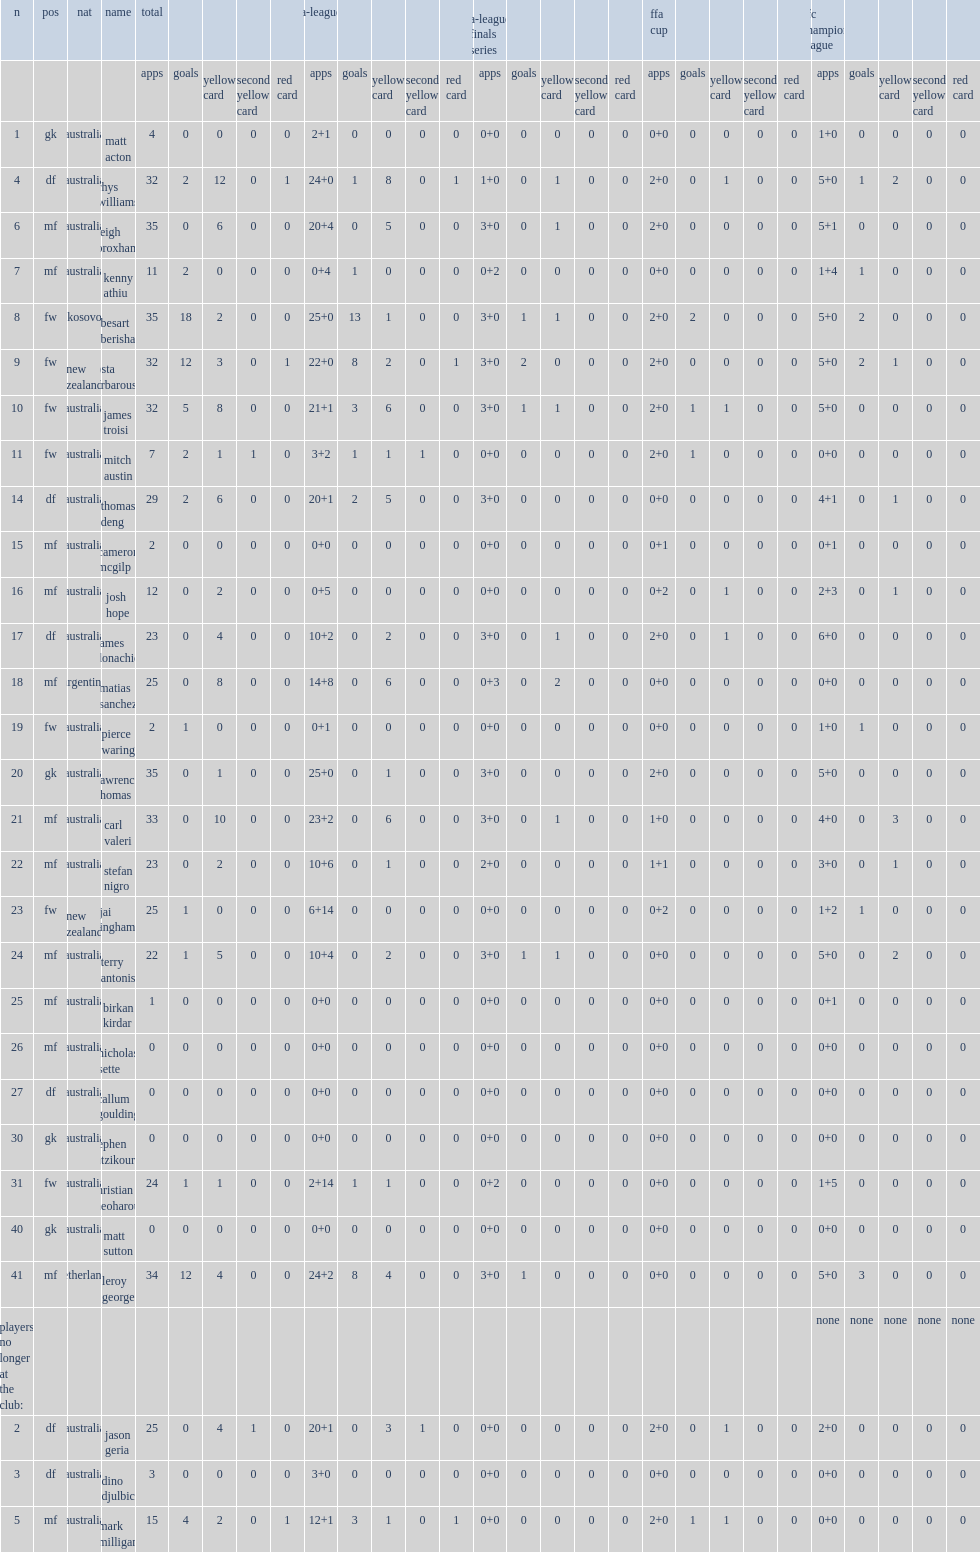List the matches that the melbourne victory fc participated in. A-league ffa cup afc champions league. Help me parse the entirety of this table. {'header': ['n', 'pos', 'nat', 'name', 'total', '', '', '', '', 'a-league', '', '', '', '', 'a-league finals series', '', '', '', '', 'ffa cup', '', '', '', '', 'afc champions league', '', '', '', ''], 'rows': [['', '', '', '', 'apps', 'goals', 'yellow card', 'second yellow card', 'red card', 'apps', 'goals', 'yellow card', 'second yellow card', 'red card', 'apps', 'goals', 'yellow card', 'second yellow card', 'red card', 'apps', 'goals', 'yellow card', 'second yellow card', 'red card', 'apps', 'goals', 'yellow card', 'second yellow card', 'red card'], ['1', 'gk', 'australia', 'matt acton', '4', '0', '0', '0', '0', '2+1', '0', '0', '0', '0', '0+0', '0', '0', '0', '0', '0+0', '0', '0', '0', '0', '1+0', '0', '0', '0', '0'], ['4', 'df', 'australia', 'rhys williams', '32', '2', '12', '0', '1', '24+0', '1', '8', '0', '1', '1+0', '0', '1', '0', '0', '2+0', '0', '1', '0', '0', '5+0', '1', '2', '0', '0'], ['6', 'mf', 'australia', 'leigh broxham', '35', '0', '6', '0', '0', '20+4', '0', '5', '0', '0', '3+0', '0', '1', '0', '0', '2+0', '0', '0', '0', '0', '5+1', '0', '0', '0', '0'], ['7', 'mf', 'australia', 'kenny athiu', '11', '2', '0', '0', '0', '0+4', '1', '0', '0', '0', '0+2', '0', '0', '0', '0', '0+0', '0', '0', '0', '0', '1+4', '1', '0', '0', '0'], ['8', 'fw', 'kosovo', 'besart berisha', '35', '18', '2', '0', '0', '25+0', '13', '1', '0', '0', '3+0', '1', '1', '0', '0', '2+0', '2', '0', '0', '0', '5+0', '2', '0', '0', '0'], ['9', 'fw', 'new zealand', 'kosta barbarouses', '32', '12', '3', '0', '1', '22+0', '8', '2', '0', '1', '3+0', '2', '0', '0', '0', '2+0', '0', '0', '0', '0', '5+0', '2', '1', '0', '0'], ['10', 'fw', 'australia', 'james troisi', '32', '5', '8', '0', '0', '21+1', '3', '6', '0', '0', '3+0', '1', '1', '0', '0', '2+0', '1', '1', '0', '0', '5+0', '0', '0', '0', '0'], ['11', 'fw', 'australia', 'mitch austin', '7', '2', '1', '1', '0', '3+2', '1', '1', '1', '0', '0+0', '0', '0', '0', '0', '2+0', '1', '0', '0', '0', '0+0', '0', '0', '0', '0'], ['14', 'df', 'australia', 'thomas deng', '29', '2', '6', '0', '0', '20+1', '2', '5', '0', '0', '3+0', '0', '0', '0', '0', '0+0', '0', '0', '0', '0', '4+1', '0', '1', '0', '0'], ['15', 'mf', 'australia', 'cameron mcgilp', '2', '0', '0', '0', '0', '0+0', '0', '0', '0', '0', '0+0', '0', '0', '0', '0', '0+1', '0', '0', '0', '0', '0+1', '0', '0', '0', '0'], ['16', 'mf', 'australia', 'josh hope', '12', '0', '2', '0', '0', '0+5', '0', '0', '0', '0', '0+0', '0', '0', '0', '0', '0+2', '0', '1', '0', '0', '2+3', '0', '1', '0', '0'], ['17', 'df', 'australia', 'james donachie', '23', '0', '4', '0', '0', '10+2', '0', '2', '0', '0', '3+0', '0', '1', '0', '0', '2+0', '0', '1', '0', '0', '6+0', '0', '0', '0', '0'], ['18', 'mf', 'argentina', 'matias sanchez', '25', '0', '8', '0', '0', '14+8', '0', '6', '0', '0', '0+3', '0', '2', '0', '0', '0+0', '0', '0', '0', '0', '0+0', '0', '0', '0', '0'], ['19', 'fw', 'australia', 'pierce waring', '2', '1', '0', '0', '0', '0+1', '0', '0', '0', '0', '0+0', '0', '0', '0', '0', '0+0', '0', '0', '0', '0', '1+0', '1', '0', '0', '0'], ['20', 'gk', 'australia', 'lawrence thomas', '35', '0', '1', '0', '0', '25+0', '0', '1', '0', '0', '3+0', '0', '0', '0', '0', '2+0', '0', '0', '0', '0', '5+0', '0', '0', '0', '0'], ['21', 'mf', 'australia', 'carl valeri', '33', '0', '10', '0', '0', '23+2', '0', '6', '0', '0', '3+0', '0', '1', '0', '0', '1+0', '0', '0', '0', '0', '4+0', '0', '3', '0', '0'], ['22', 'mf', 'australia', 'stefan nigro', '23', '0', '2', '0', '0', '10+6', '0', '1', '0', '0', '2+0', '0', '0', '0', '0', '1+1', '0', '0', '0', '0', '3+0', '0', '1', '0', '0'], ['23', 'fw', 'new zealand', 'jai ingham', '25', '1', '0', '0', '0', '6+14', '0', '0', '0', '0', '0+0', '0', '0', '0', '0', '0+2', '0', '0', '0', '0', '1+2', '1', '0', '0', '0'], ['24', 'mf', 'australia', 'terry antonis', '22', '1', '5', '0', '0', '10+4', '0', '2', '0', '0', '3+0', '1', '1', '0', '0', '0+0', '0', '0', '0', '0', '5+0', '0', '2', '0', '0'], ['25', 'mf', 'australia', 'birkan kirdar', '1', '0', '0', '0', '0', '0+0', '0', '0', '0', '0', '0+0', '0', '0', '0', '0', '0+0', '0', '0', '0', '0', '0+1', '0', '0', '0', '0'], ['26', 'mf', 'australia', 'nicholas sette', '0', '0', '0', '0', '0', '0+0', '0', '0', '0', '0', '0+0', '0', '0', '0', '0', '0+0', '0', '0', '0', '0', '0+0', '0', '0', '0', '0'], ['27', 'df', 'australia', 'callum goulding', '0', '0', '0', '0', '0', '0+0', '0', '0', '0', '0', '0+0', '0', '0', '0', '0', '0+0', '0', '0', '0', '0', '0+0', '0', '0', '0', '0'], ['30', 'gk', 'australia', 'stephen hatzikourtis', '0', '0', '0', '0', '0', '0+0', '0', '0', '0', '0', '0+0', '0', '0', '0', '0', '0+0', '0', '0', '0', '0', '0+0', '0', '0', '0', '0'], ['31', 'fw', 'australia', 'christian theoharous', '24', '1', '1', '0', '0', '2+14', '1', '1', '0', '0', '0+2', '0', '0', '0', '0', '0+0', '0', '0', '0', '0', '1+5', '0', '0', '0', '0'], ['40', 'gk', 'australia', 'matt sutton', '0', '0', '0', '0', '0', '0+0', '0', '0', '0', '0', '0+0', '0', '0', '0', '0', '0+0', '0', '0', '0', '0', '0+0', '0', '0', '0', '0'], ['41', 'mf', 'netherlands', 'leroy george', '34', '12', '4', '0', '0', '24+2', '8', '4', '0', '0', '3+0', '1', '0', '0', '0', '0+0', '0', '0', '0', '0', '5+0', '3', '0', '0', '0'], ['players no longer at the club:', '', '', '', '', '', '', '', '', '', '', '', '', '', '', '', '', '', '', '', '', '', '', '', 'none', 'none', 'none', 'none', 'none'], ['2', 'df', 'australia', 'jason geria', '25', '0', '4', '1', '0', '20+1', '0', '3', '1', '0', '0+0', '0', '0', '0', '0', '2+0', '0', '1', '0', '0', '2+0', '0', '0', '0', '0'], ['3', 'df', 'australia', 'dino djulbic', '3', '0', '0', '0', '0', '3+0', '0', '0', '0', '0', '0+0', '0', '0', '0', '0', '0+0', '0', '0', '0', '0', '0+0', '0', '0', '0', '0'], ['5', 'mf', 'australia', 'mark milligan', '15', '4', '2', '0', '1', '12+1', '3', '1', '0', '1', '0+0', '0', '0', '0', '0', '2+0', '1', '1', '0', '0', '0+0', '0', '0', '0', '0']]} 